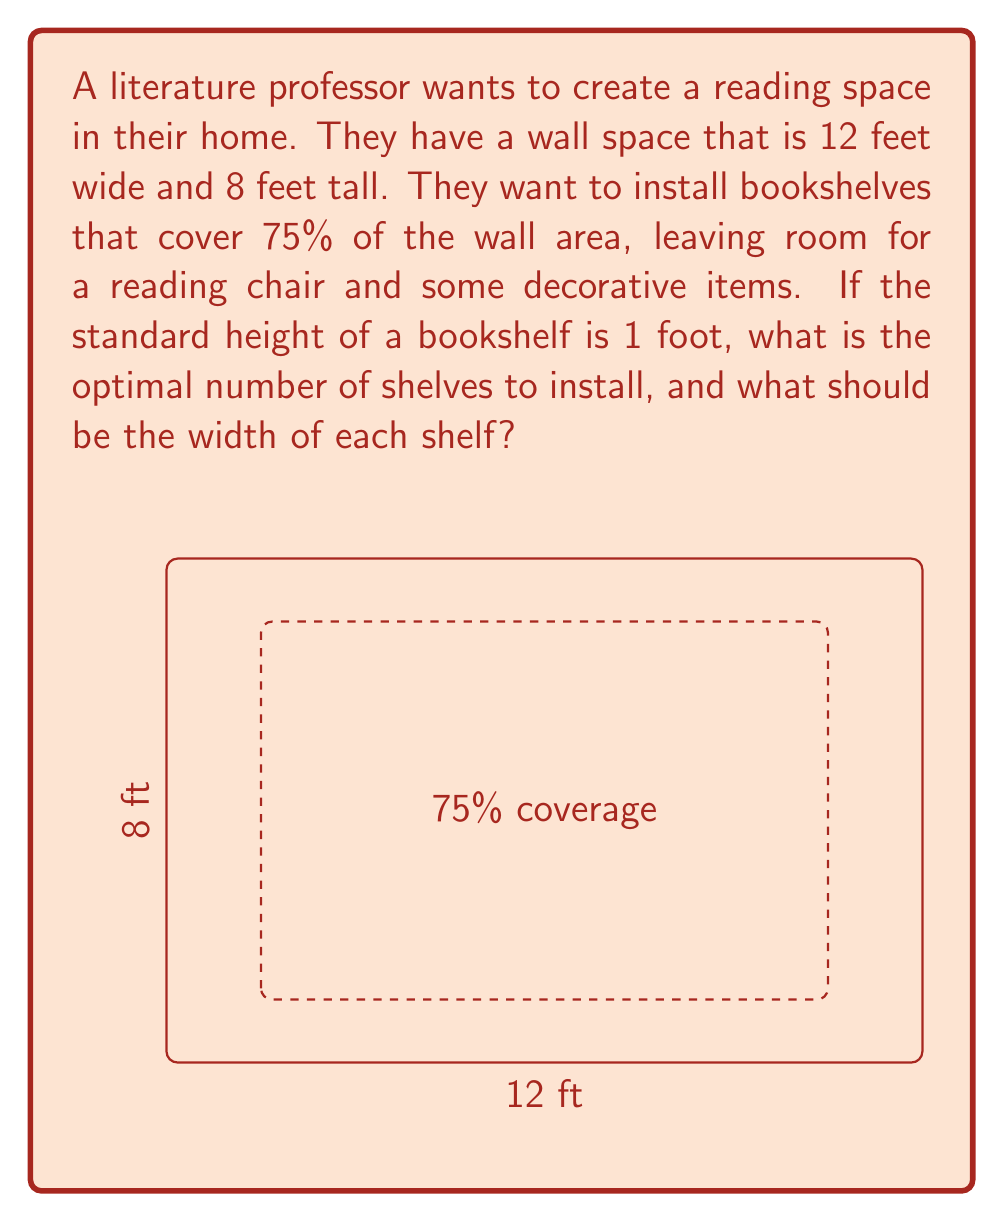Show me your answer to this math problem. Let's approach this step-by-step:

1) First, calculate the total wall area:
   $A_{total} = 12 \text{ ft} \times 8 \text{ ft} = 96 \text{ ft}^2$

2) Calculate 75% of the wall area for bookshelves:
   $A_{shelves} = 0.75 \times 96 \text{ ft}^2 = 72 \text{ ft}^2$

3) If each shelf is 1 foot high, we can determine the number of shelves:
   $\text{Number of shelves} = \frac{8 \text{ ft}}{1 \text{ ft/shelf}} = 8 \text{ shelves}$

4) Now, we need to find the width of each shelf:
   $\text{Total shelf area} = \text{Number of shelves} \times \text{Width} \times \text{Depth}$
   $72 \text{ ft}^2 = 8 \times \text{Width} \times 1 \text{ ft}$

5) Solve for width:
   $\text{Width} = \frac{72 \text{ ft}^2}{8 \times 1 \text{ ft}} = 9 \text{ ft}$

6) Check if this fits within the wall width:
   $9 \text{ ft} < 12 \text{ ft}$, so it fits with room to spare.

Therefore, the optimal solution is to install 8 shelves, each 9 feet wide and 1 foot high.
Answer: 8 shelves, each 9 ft wide 